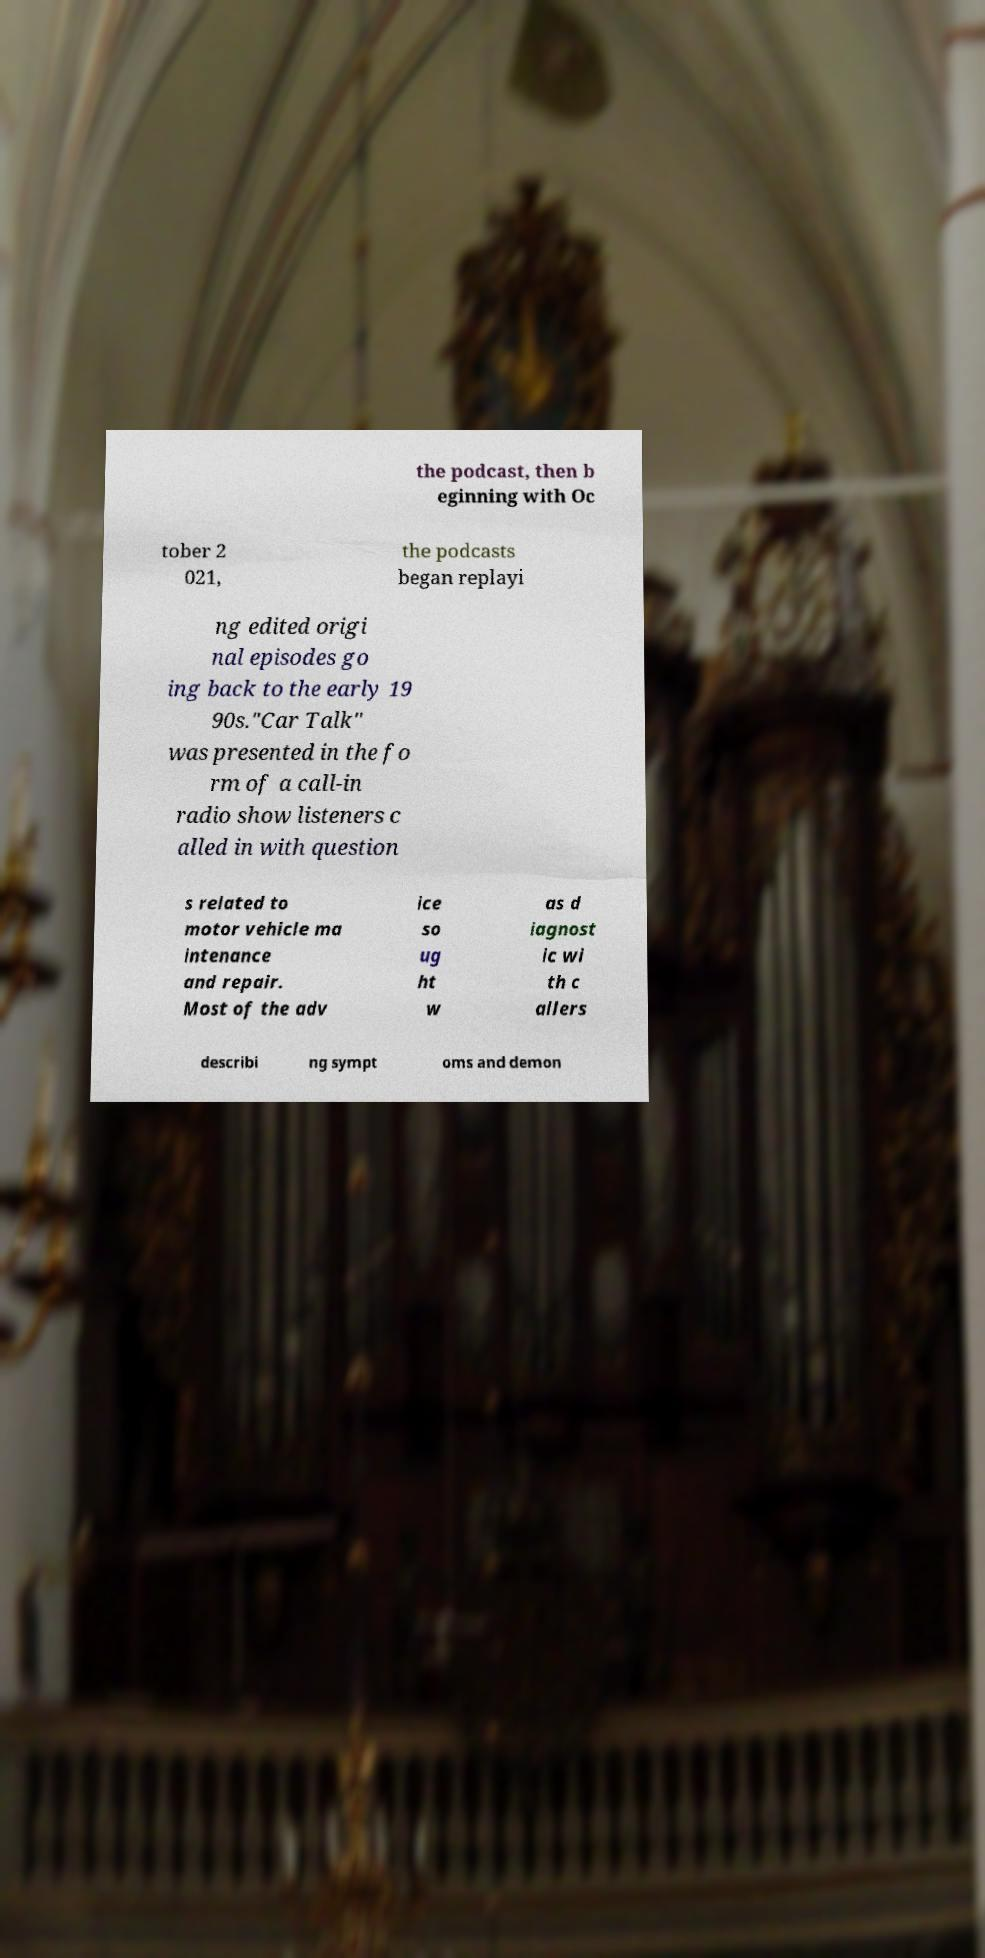What messages or text are displayed in this image? I need them in a readable, typed format. the podcast, then b eginning with Oc tober 2 021, the podcasts began replayi ng edited origi nal episodes go ing back to the early 19 90s."Car Talk" was presented in the fo rm of a call-in radio show listeners c alled in with question s related to motor vehicle ma intenance and repair. Most of the adv ice so ug ht w as d iagnost ic wi th c allers describi ng sympt oms and demon 